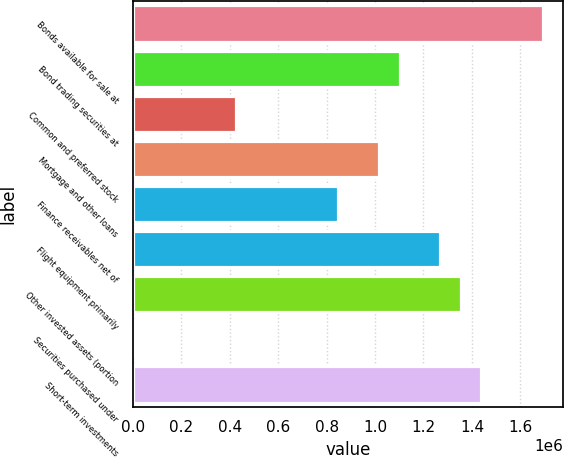Convert chart to OTSL. <chart><loc_0><loc_0><loc_500><loc_500><bar_chart><fcel>Bonds available for sale at<fcel>Bond trading securities at<fcel>Common and preferred stock<fcel>Mortgage and other loans<fcel>Finance receivables net of<fcel>Flight equipment primarily<fcel>Other invested assets (portion<fcel>Securities purchased under<fcel>Short-term investments<nl><fcel>1.69302e+06<fcel>1.10121e+06<fcel>424870<fcel>1.01667e+06<fcel>847585<fcel>1.2703e+06<fcel>1.35484e+06<fcel>2154<fcel>1.43939e+06<nl></chart> 